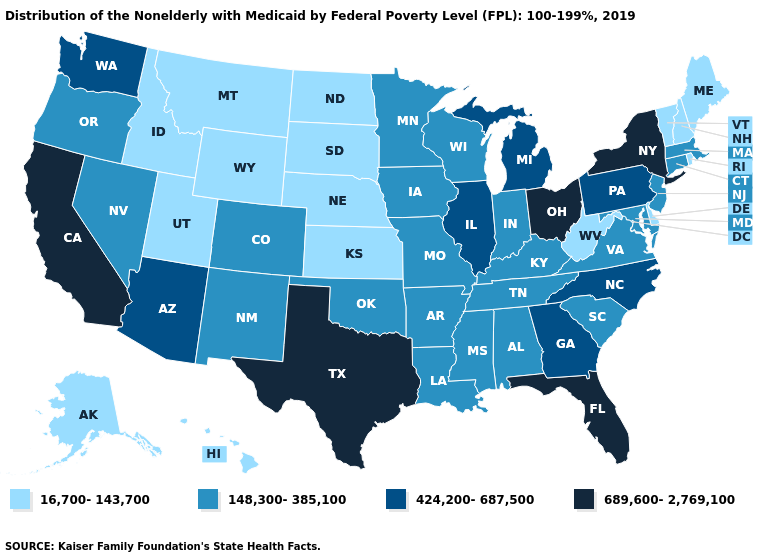Does Missouri have a lower value than Virginia?
Give a very brief answer. No. What is the value of North Dakota?
Quick response, please. 16,700-143,700. Does Texas have the lowest value in the South?
Short answer required. No. Name the states that have a value in the range 424,200-687,500?
Write a very short answer. Arizona, Georgia, Illinois, Michigan, North Carolina, Pennsylvania, Washington. Which states hav the highest value in the MidWest?
Concise answer only. Ohio. Among the states that border Washington , which have the highest value?
Give a very brief answer. Oregon. Name the states that have a value in the range 16,700-143,700?
Concise answer only. Alaska, Delaware, Hawaii, Idaho, Kansas, Maine, Montana, Nebraska, New Hampshire, North Dakota, Rhode Island, South Dakota, Utah, Vermont, West Virginia, Wyoming. Does California have the highest value in the West?
Be succinct. Yes. Does Massachusetts have a lower value than Vermont?
Keep it brief. No. Does Virginia have the same value as Kentucky?
Quick response, please. Yes. Name the states that have a value in the range 148,300-385,100?
Short answer required. Alabama, Arkansas, Colorado, Connecticut, Indiana, Iowa, Kentucky, Louisiana, Maryland, Massachusetts, Minnesota, Mississippi, Missouri, Nevada, New Jersey, New Mexico, Oklahoma, Oregon, South Carolina, Tennessee, Virginia, Wisconsin. Name the states that have a value in the range 16,700-143,700?
Keep it brief. Alaska, Delaware, Hawaii, Idaho, Kansas, Maine, Montana, Nebraska, New Hampshire, North Dakota, Rhode Island, South Dakota, Utah, Vermont, West Virginia, Wyoming. Name the states that have a value in the range 148,300-385,100?
Concise answer only. Alabama, Arkansas, Colorado, Connecticut, Indiana, Iowa, Kentucky, Louisiana, Maryland, Massachusetts, Minnesota, Mississippi, Missouri, Nevada, New Jersey, New Mexico, Oklahoma, Oregon, South Carolina, Tennessee, Virginia, Wisconsin. Does Arkansas have the lowest value in the USA?
Quick response, please. No. Does Nebraska have the lowest value in the MidWest?
Write a very short answer. Yes. 